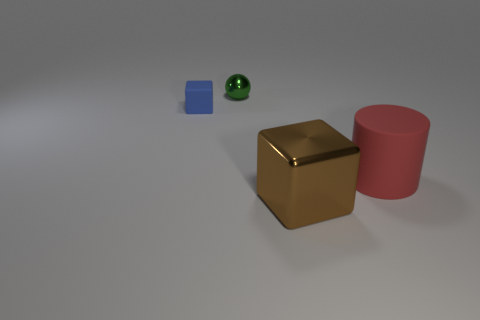Add 2 large green shiny balls. How many objects exist? 6 Subtract all cylinders. How many objects are left? 3 Subtract all rubber cubes. Subtract all cubes. How many objects are left? 1 Add 1 brown things. How many brown things are left? 2 Add 2 big blue shiny cubes. How many big blue shiny cubes exist? 2 Subtract 0 blue spheres. How many objects are left? 4 